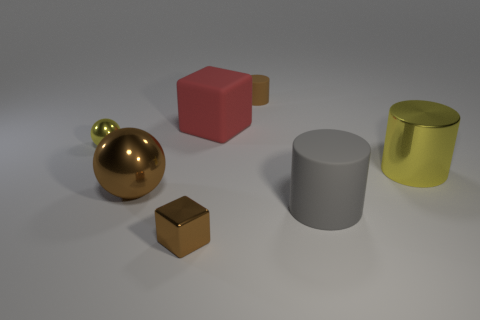What is the material of the block that is the same size as the brown cylinder?
Provide a succinct answer. Metal. There is a rubber cylinder in front of the big thing that is behind the tiny yellow metallic object; what is its color?
Your answer should be very brief. Gray. What number of brown shiny spheres are to the right of the small brown cylinder?
Ensure brevity in your answer.  0. The small cube is what color?
Make the answer very short. Brown. How many small things are either spheres or matte objects?
Your answer should be compact. 2. There is a block in front of the large brown object; does it have the same color as the rubber cylinder that is behind the small yellow thing?
Your answer should be compact. Yes. What number of other things are the same color as the shiny cylinder?
Your answer should be very brief. 1. The small object right of the rubber cube has what shape?
Your response must be concise. Cylinder. Is the number of red cylinders less than the number of big metallic things?
Keep it short and to the point. Yes. Is the yellow thing that is to the left of the big brown metallic sphere made of the same material as the large brown object?
Make the answer very short. Yes. 